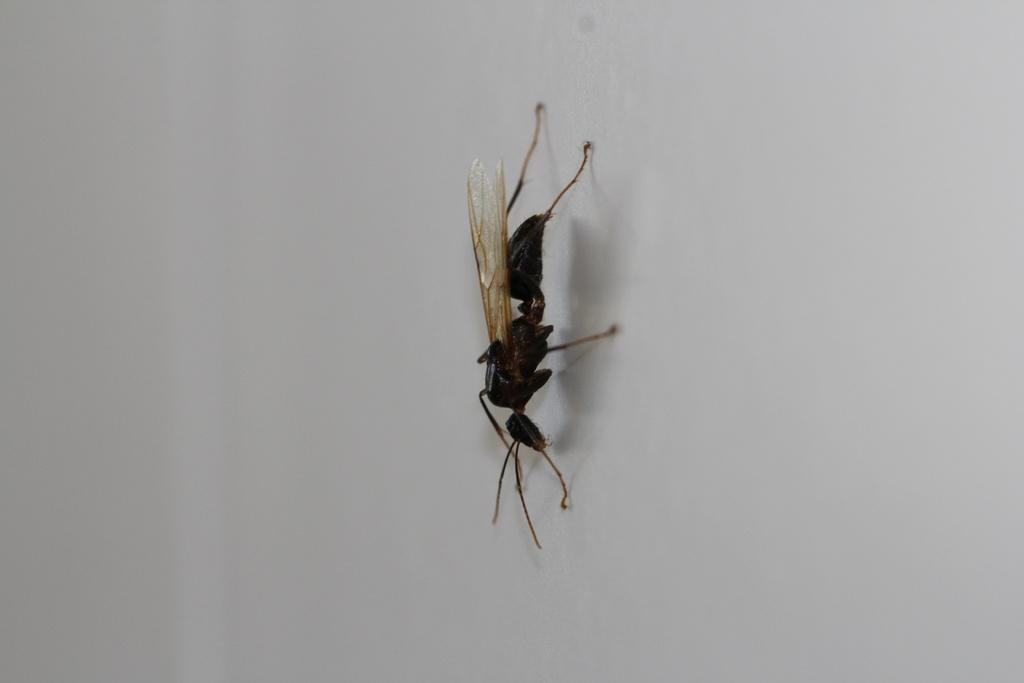What type of insect is present in the image? There is a black color hornet in the image. What type of lace is being used to decorate the box in the image? There is no box or lace present in the image; it only features a black color hornet. 